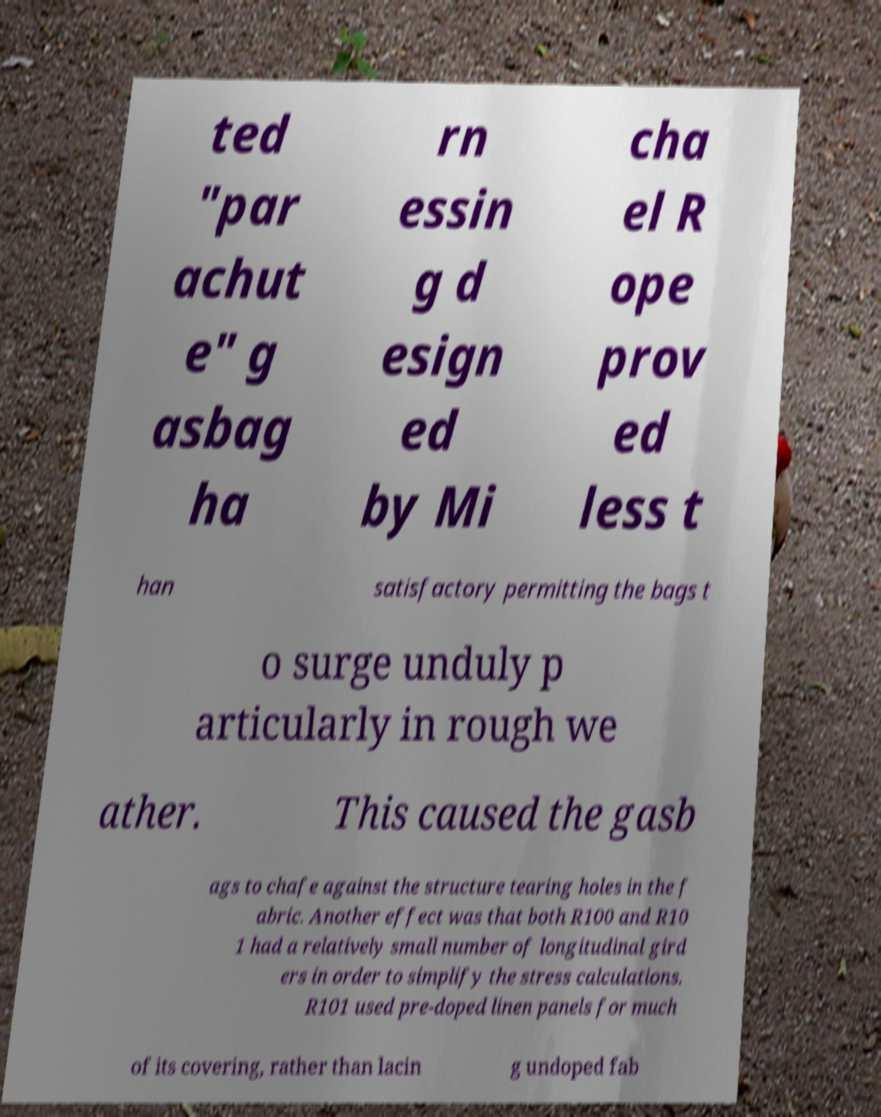Can you accurately transcribe the text from the provided image for me? ted "par achut e" g asbag ha rn essin g d esign ed by Mi cha el R ope prov ed less t han satisfactory permitting the bags t o surge unduly p articularly in rough we ather. This caused the gasb ags to chafe against the structure tearing holes in the f abric. Another effect was that both R100 and R10 1 had a relatively small number of longitudinal gird ers in order to simplify the stress calculations. R101 used pre-doped linen panels for much of its covering, rather than lacin g undoped fab 